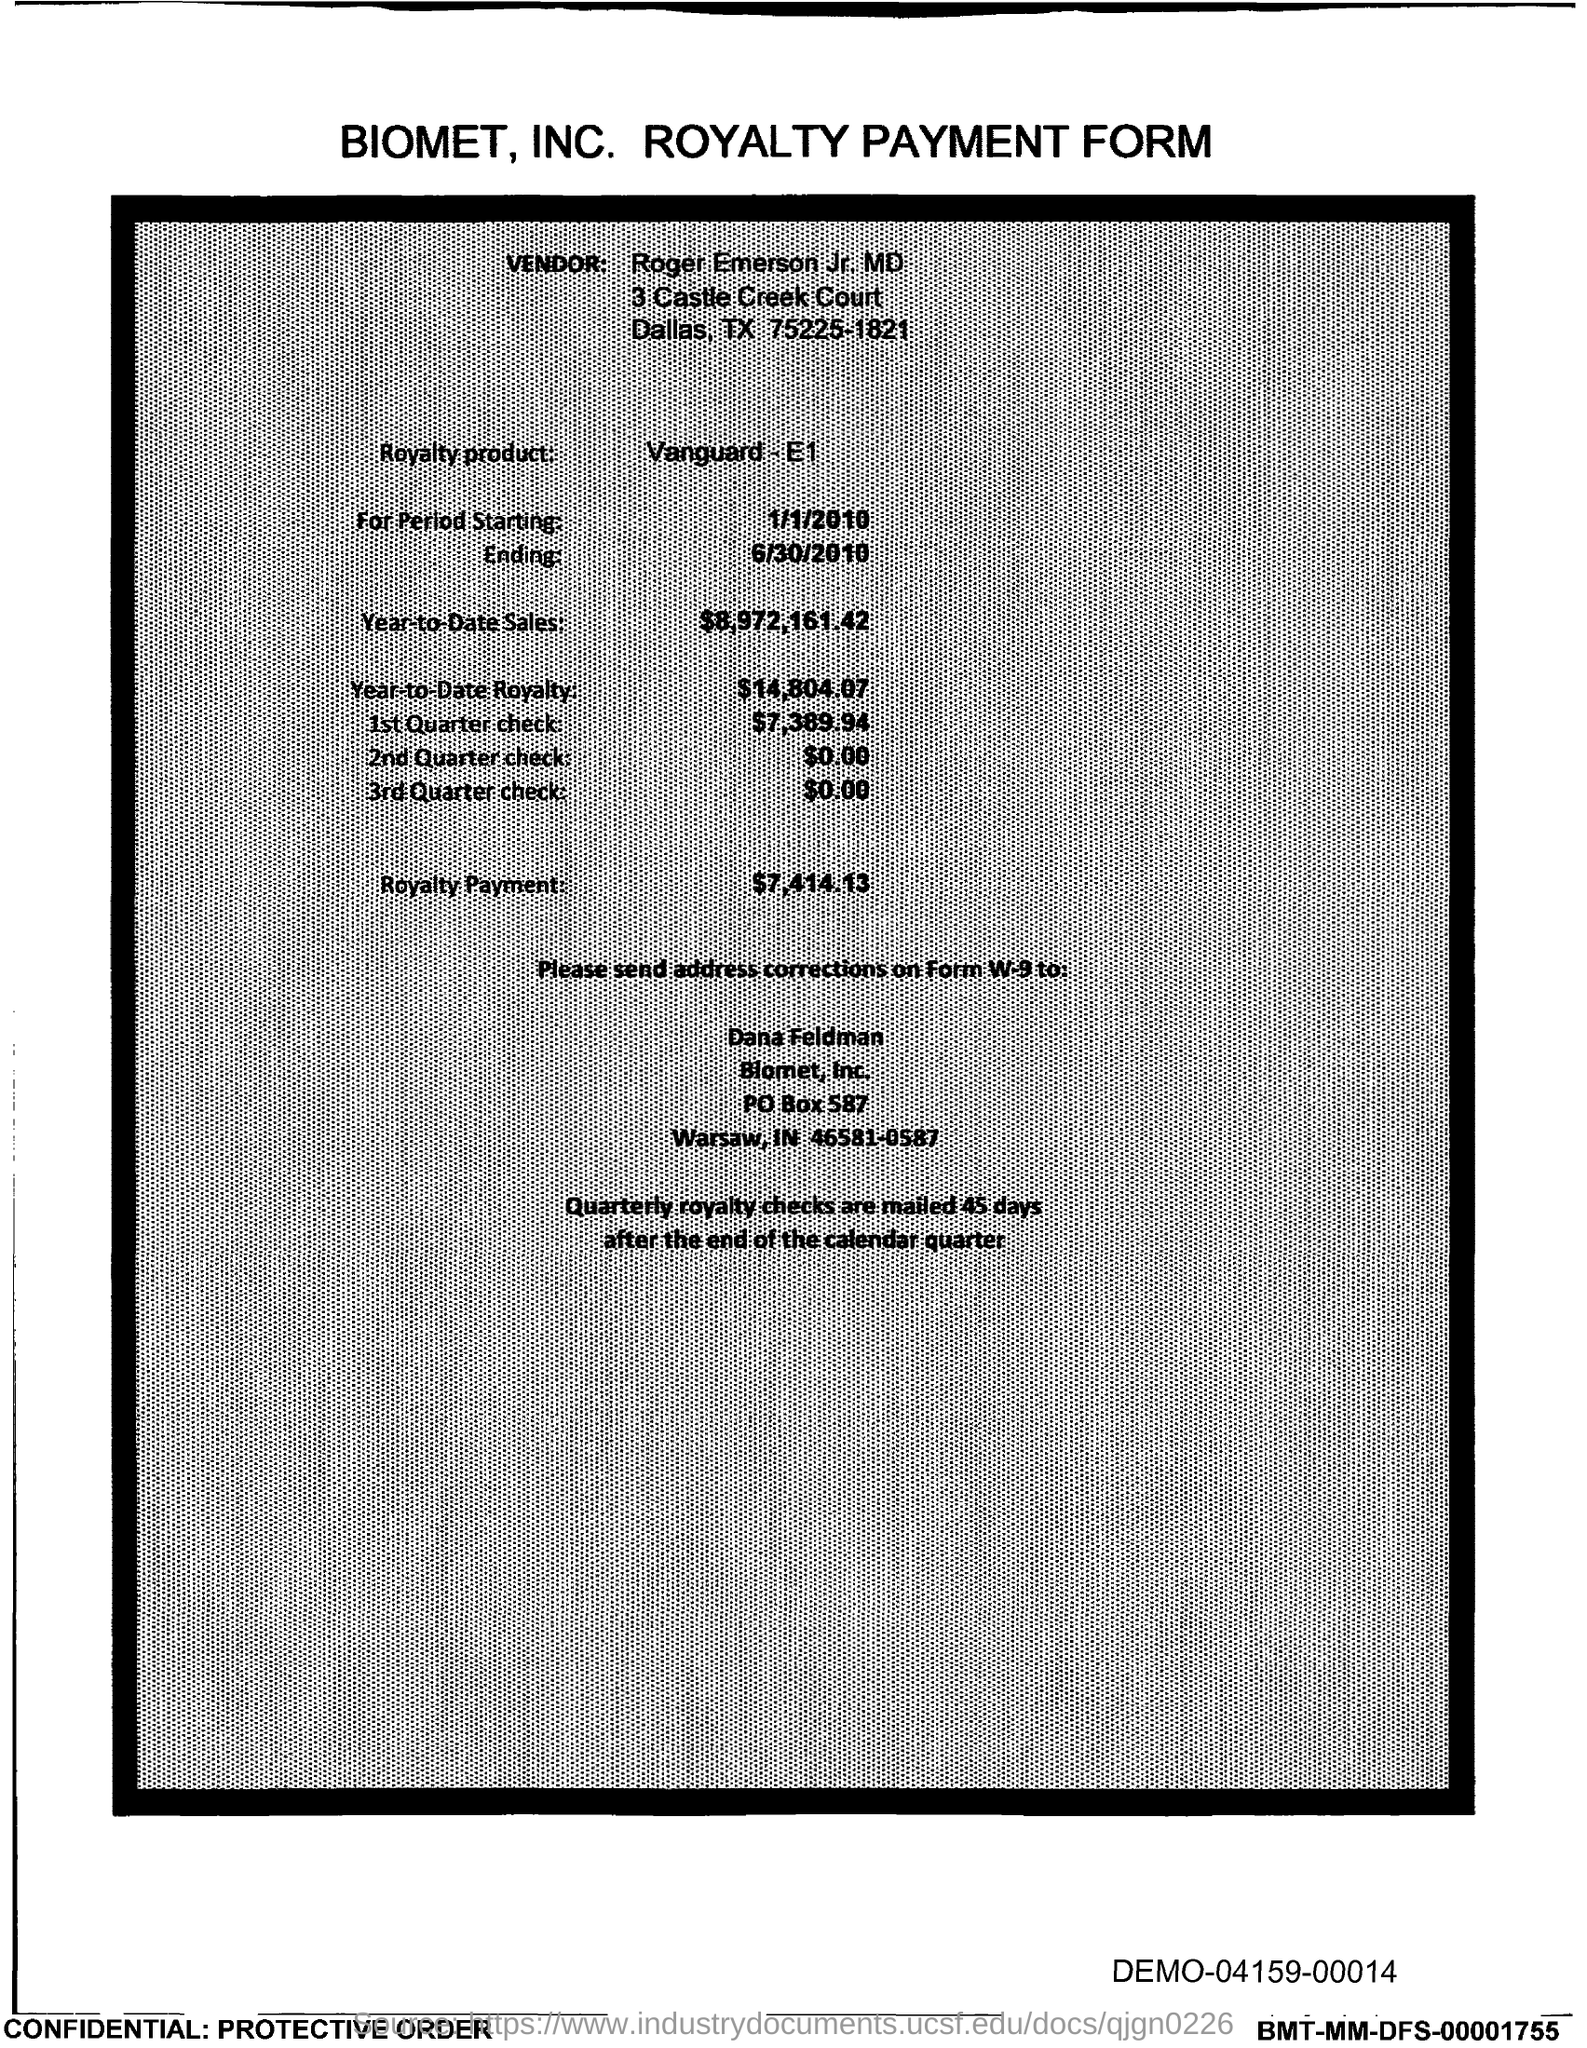Point out several critical features in this image. The PO Box number mentioned in the document is 587. 